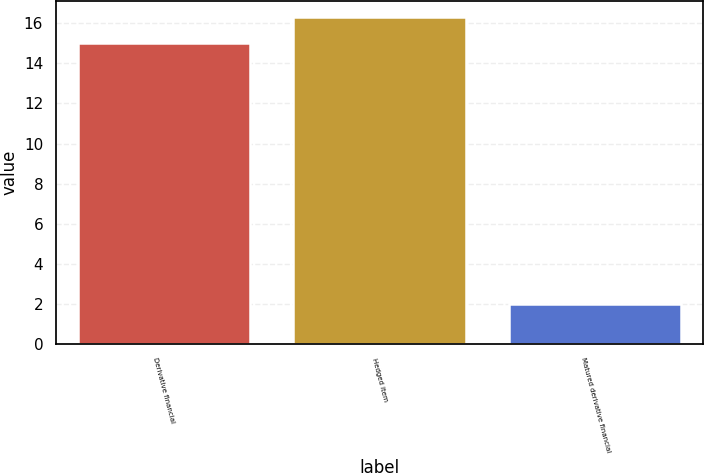Convert chart to OTSL. <chart><loc_0><loc_0><loc_500><loc_500><bar_chart><fcel>Derivative financial<fcel>Hedged item<fcel>Matured derivative financial<nl><fcel>15<fcel>16.3<fcel>2<nl></chart> 